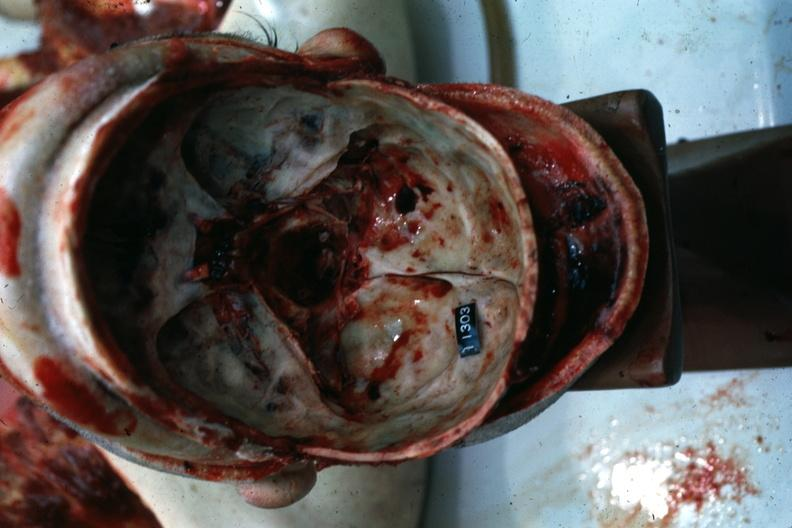does rheumatoid arthritis show multiple fractures?
Answer the question using a single word or phrase. No 